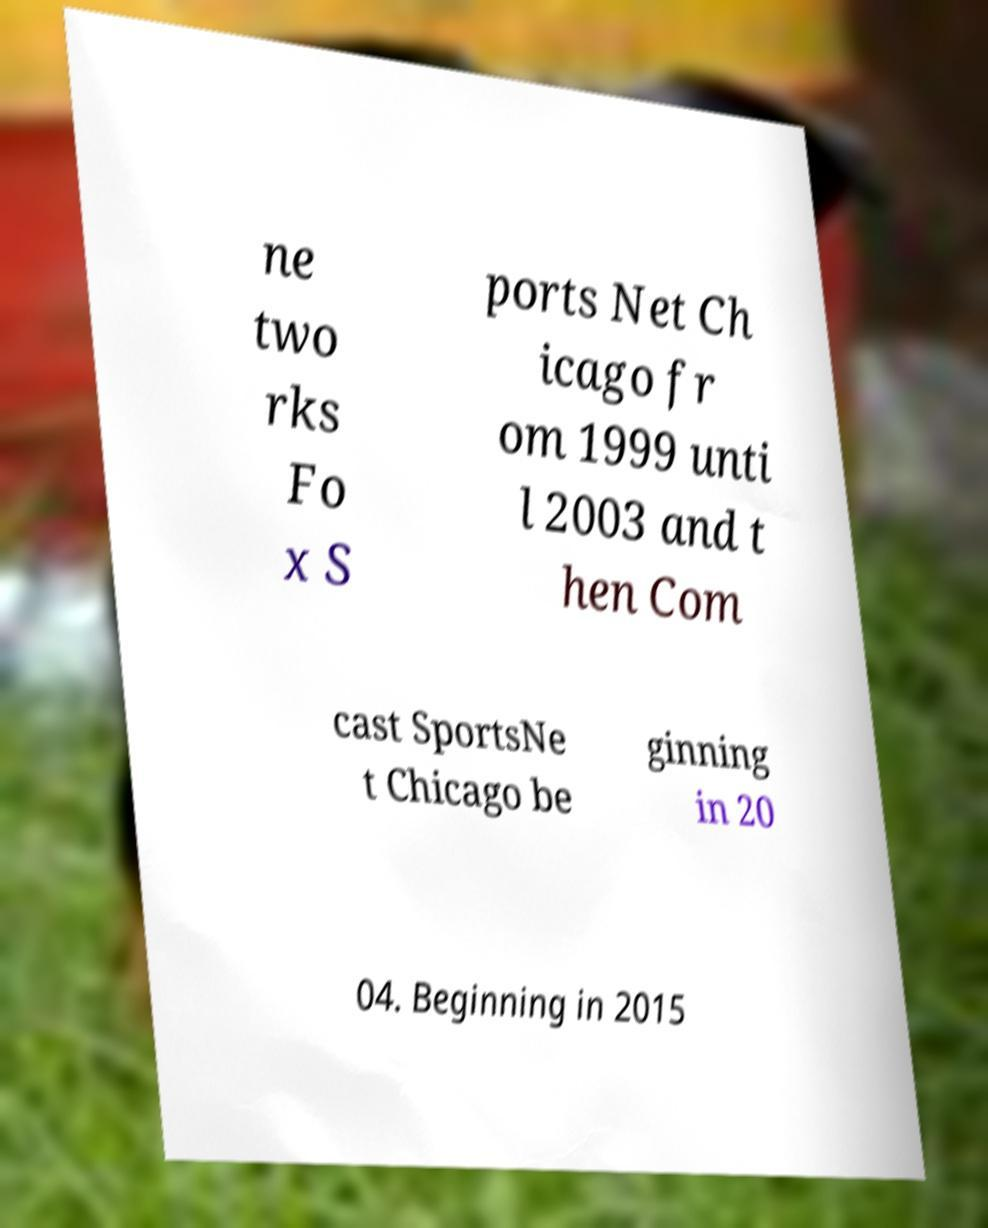Can you accurately transcribe the text from the provided image for me? ne two rks Fo x S ports Net Ch icago fr om 1999 unti l 2003 and t hen Com cast SportsNe t Chicago be ginning in 20 04. Beginning in 2015 